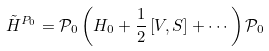<formula> <loc_0><loc_0><loc_500><loc_500>\tilde { H } ^ { P _ { 0 } } = \mathcal { P } _ { 0 } \left ( H _ { 0 } + \frac { 1 } { 2 } \left [ V , S \right ] + \cdots \right ) \mathcal { P } _ { 0 }</formula> 